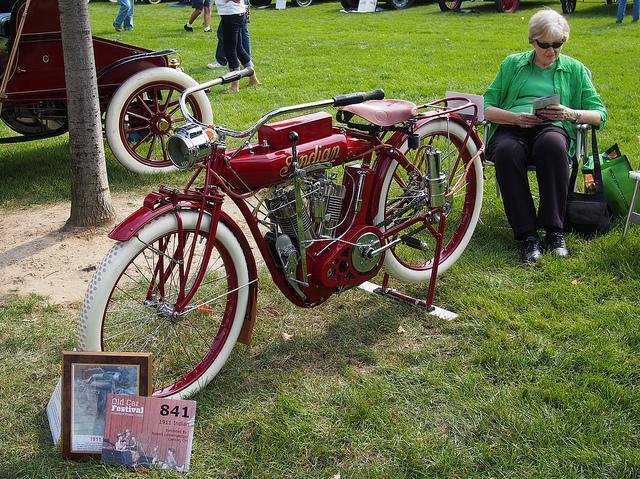For what purpose is this bike being exhibited?
Pick the correct solution from the four options below to address the question.
Options: Sale, no reason, parked temporarily, display only. Display only. 